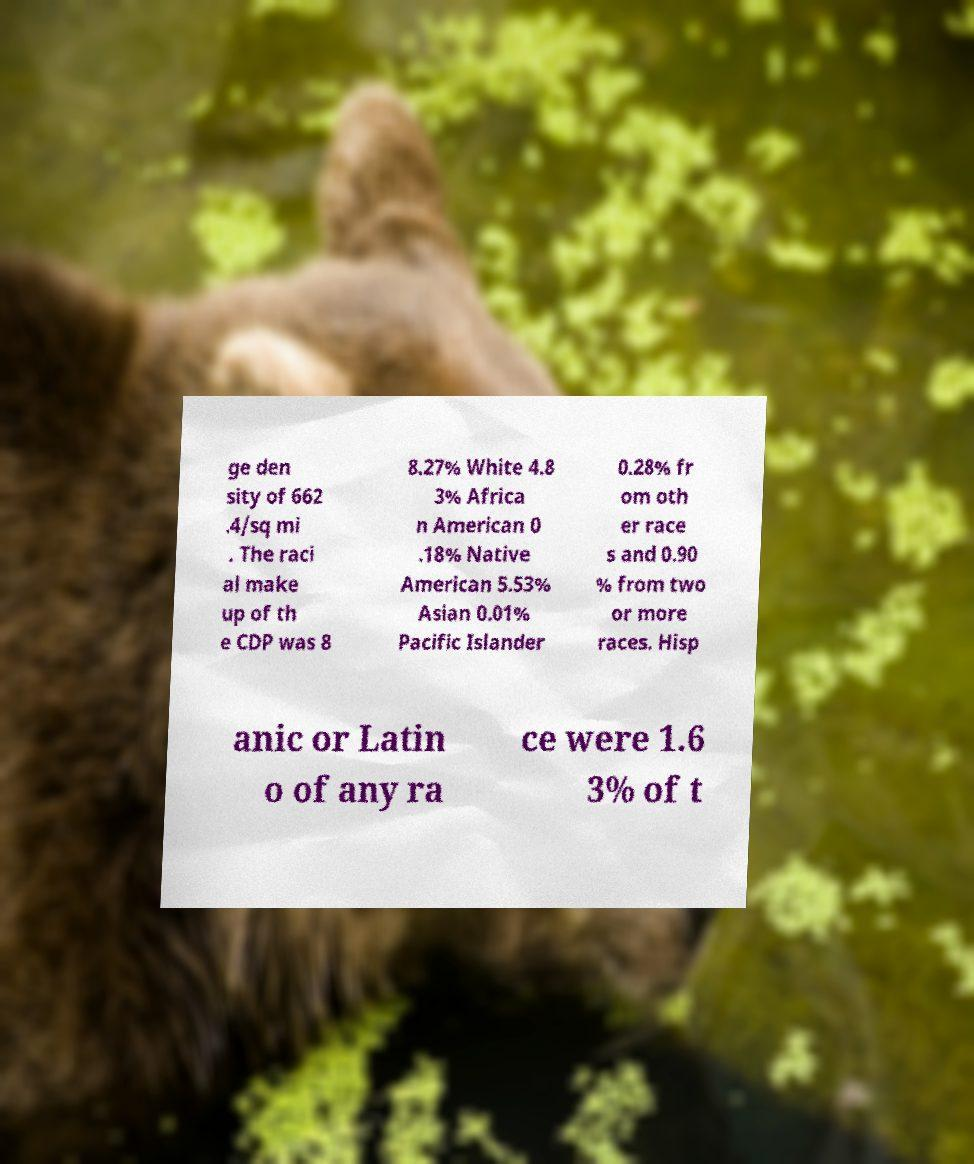Please identify and transcribe the text found in this image. ge den sity of 662 .4/sq mi . The raci al make up of th e CDP was 8 8.27% White 4.8 3% Africa n American 0 .18% Native American 5.53% Asian 0.01% Pacific Islander 0.28% fr om oth er race s and 0.90 % from two or more races. Hisp anic or Latin o of any ra ce were 1.6 3% of t 